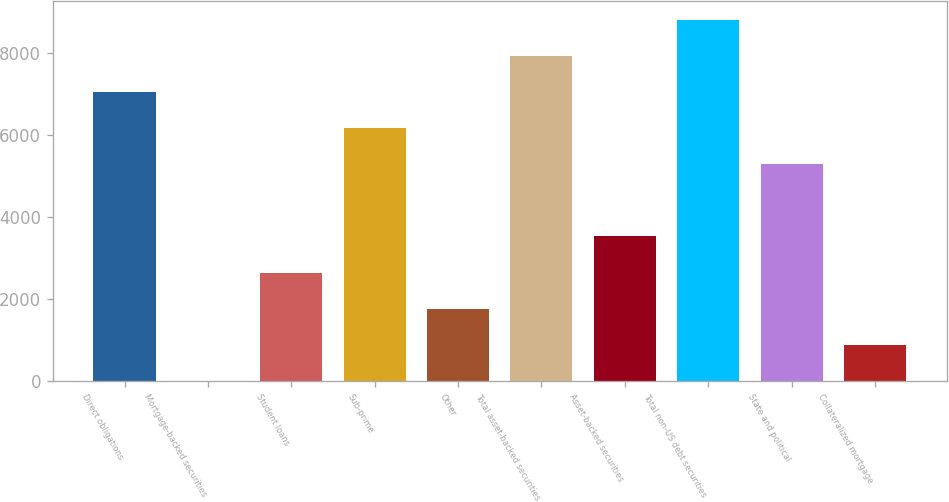Convert chart. <chart><loc_0><loc_0><loc_500><loc_500><bar_chart><fcel>Direct obligations<fcel>Mortgage-backed securities<fcel>Student loans<fcel>Sub-prime<fcel>Other<fcel>Total asset-backed securities<fcel>Asset-backed securities<fcel>Total non-US debt securities<fcel>State and political<fcel>Collateralized mortgage<nl><fcel>7045<fcel>5<fcel>2645<fcel>6165<fcel>1765<fcel>7925<fcel>3525<fcel>8805<fcel>5285<fcel>885<nl></chart> 